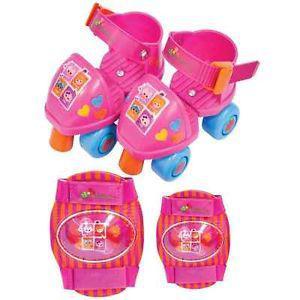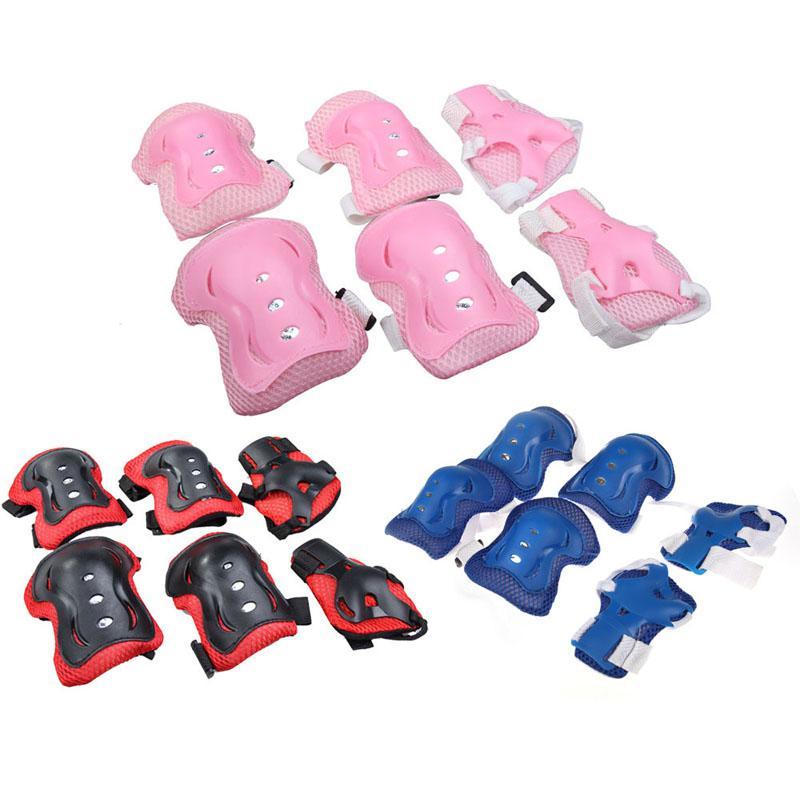The first image is the image on the left, the second image is the image on the right. Analyze the images presented: Is the assertion "All images have both knee pads and gloves." valid? Answer yes or no. No. The first image is the image on the left, the second image is the image on the right. Given the left and right images, does the statement "One image contains exactly two roller skates and two pads." hold true? Answer yes or no. Yes. 